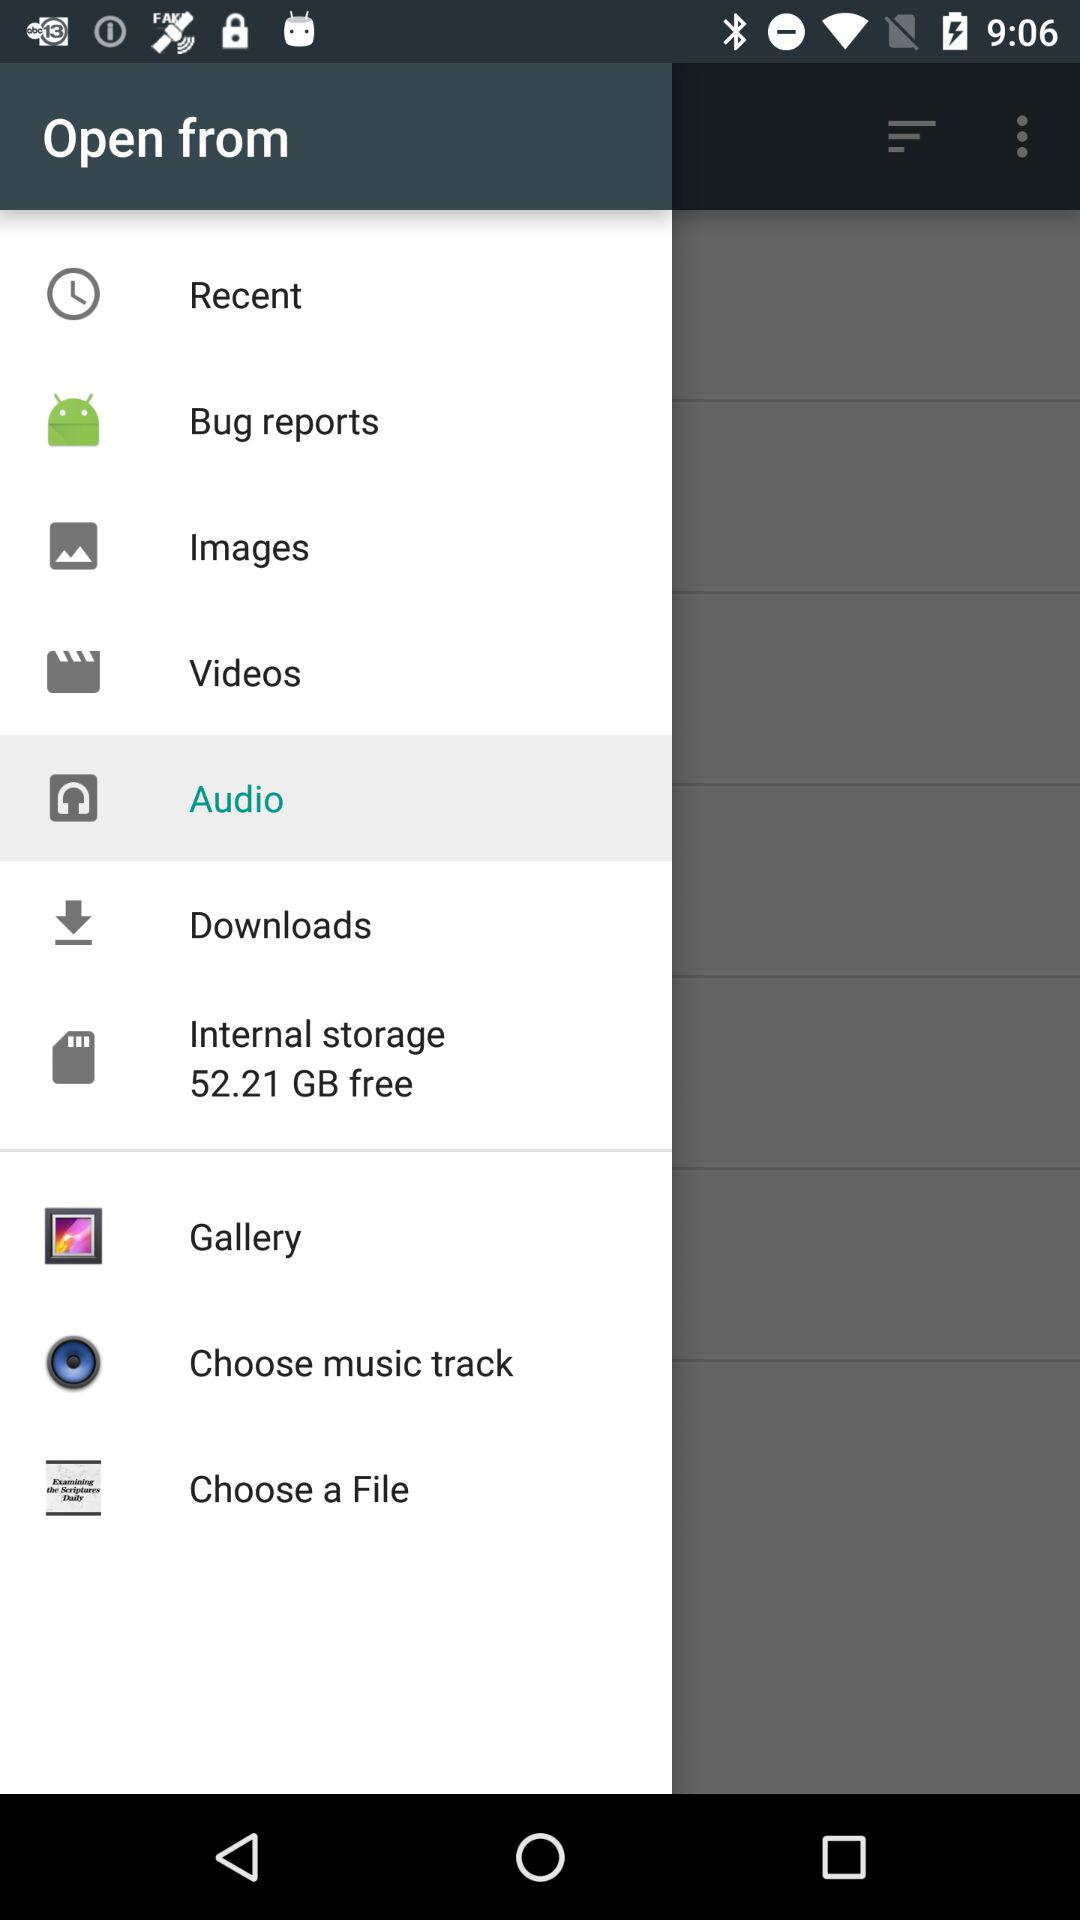How much internal storage is free? The free internal storage is 52.21 GB. 